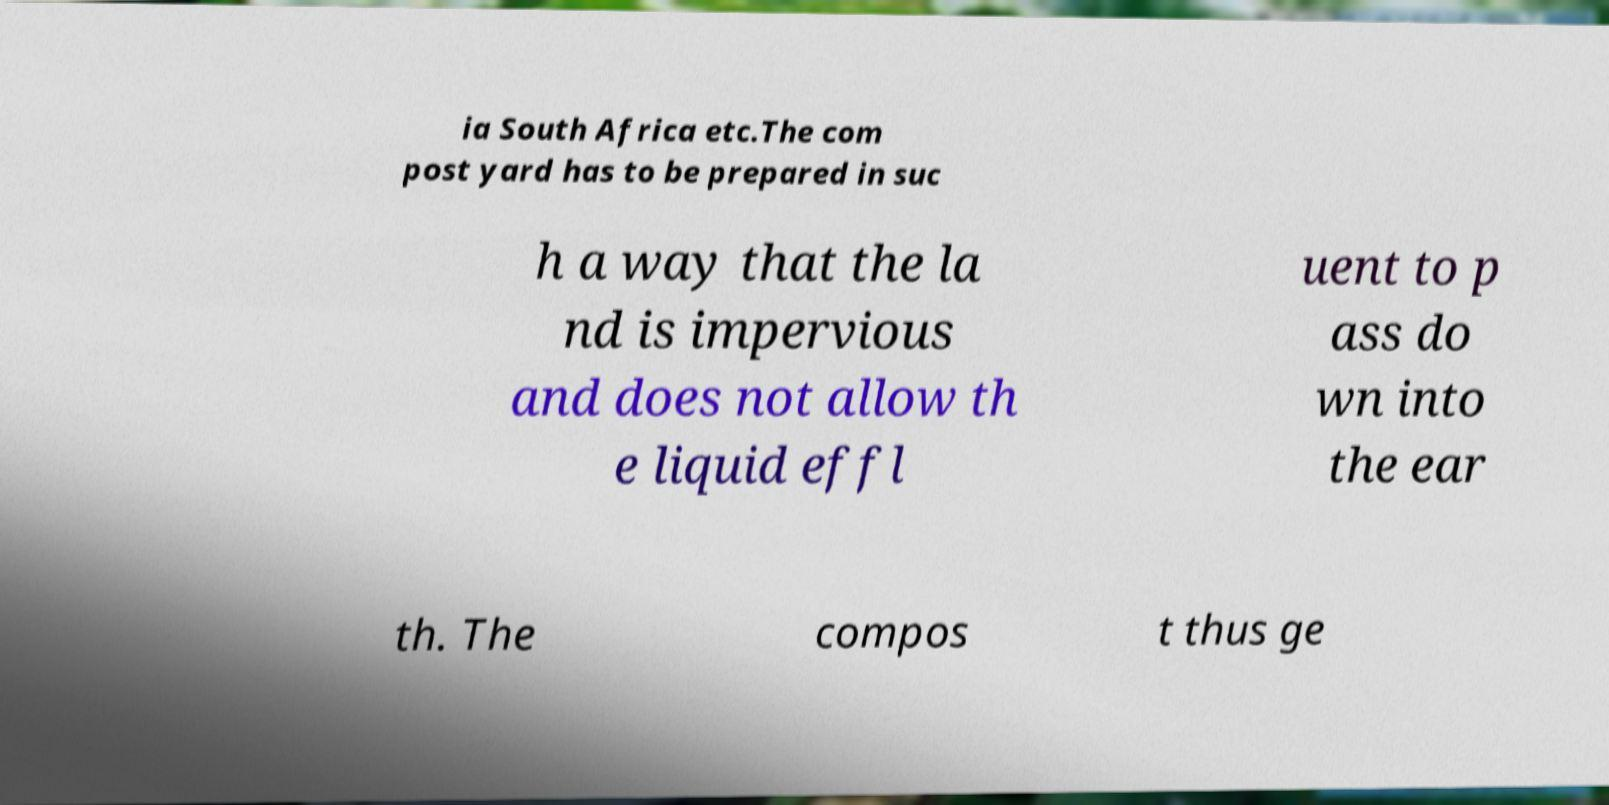Can you accurately transcribe the text from the provided image for me? ia South Africa etc.The com post yard has to be prepared in suc h a way that the la nd is impervious and does not allow th e liquid effl uent to p ass do wn into the ear th. The compos t thus ge 